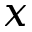Convert formula to latex. <formula><loc_0><loc_0><loc_500><loc_500>x</formula> 